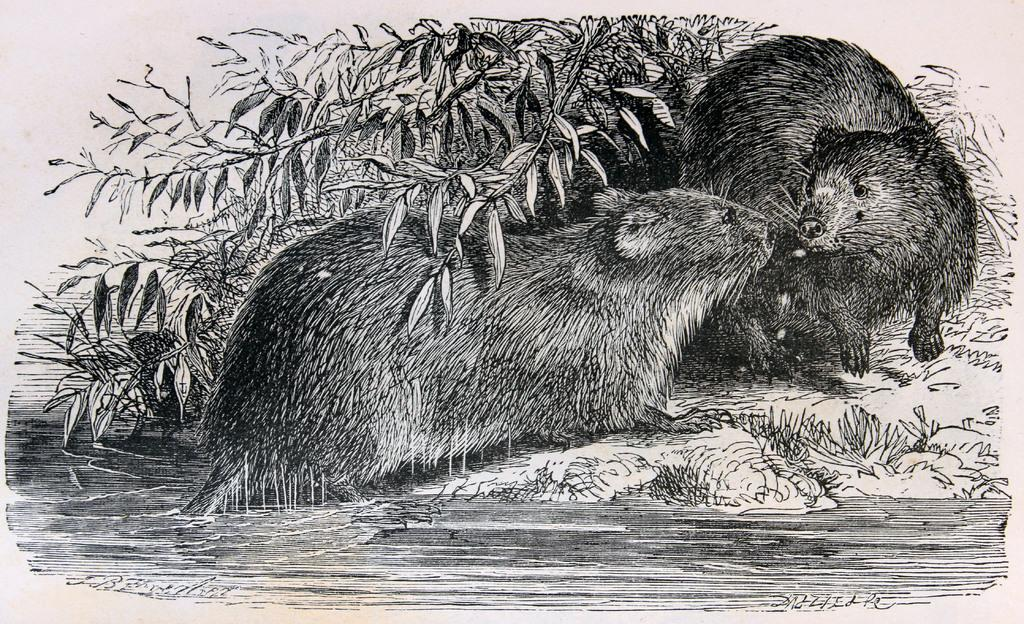What is depicted in the picture? There is a drawing in the picture. What types of living organisms are included in the drawing? The drawing includes animals and plants. What natural element is included in the drawing? The drawing includes water. On what surface is the drawing made? The drawing is on a paper. What type of wing is depicted in the drawing? There is no wing depicted in the drawing; it includes animals and plants, but not wings. 